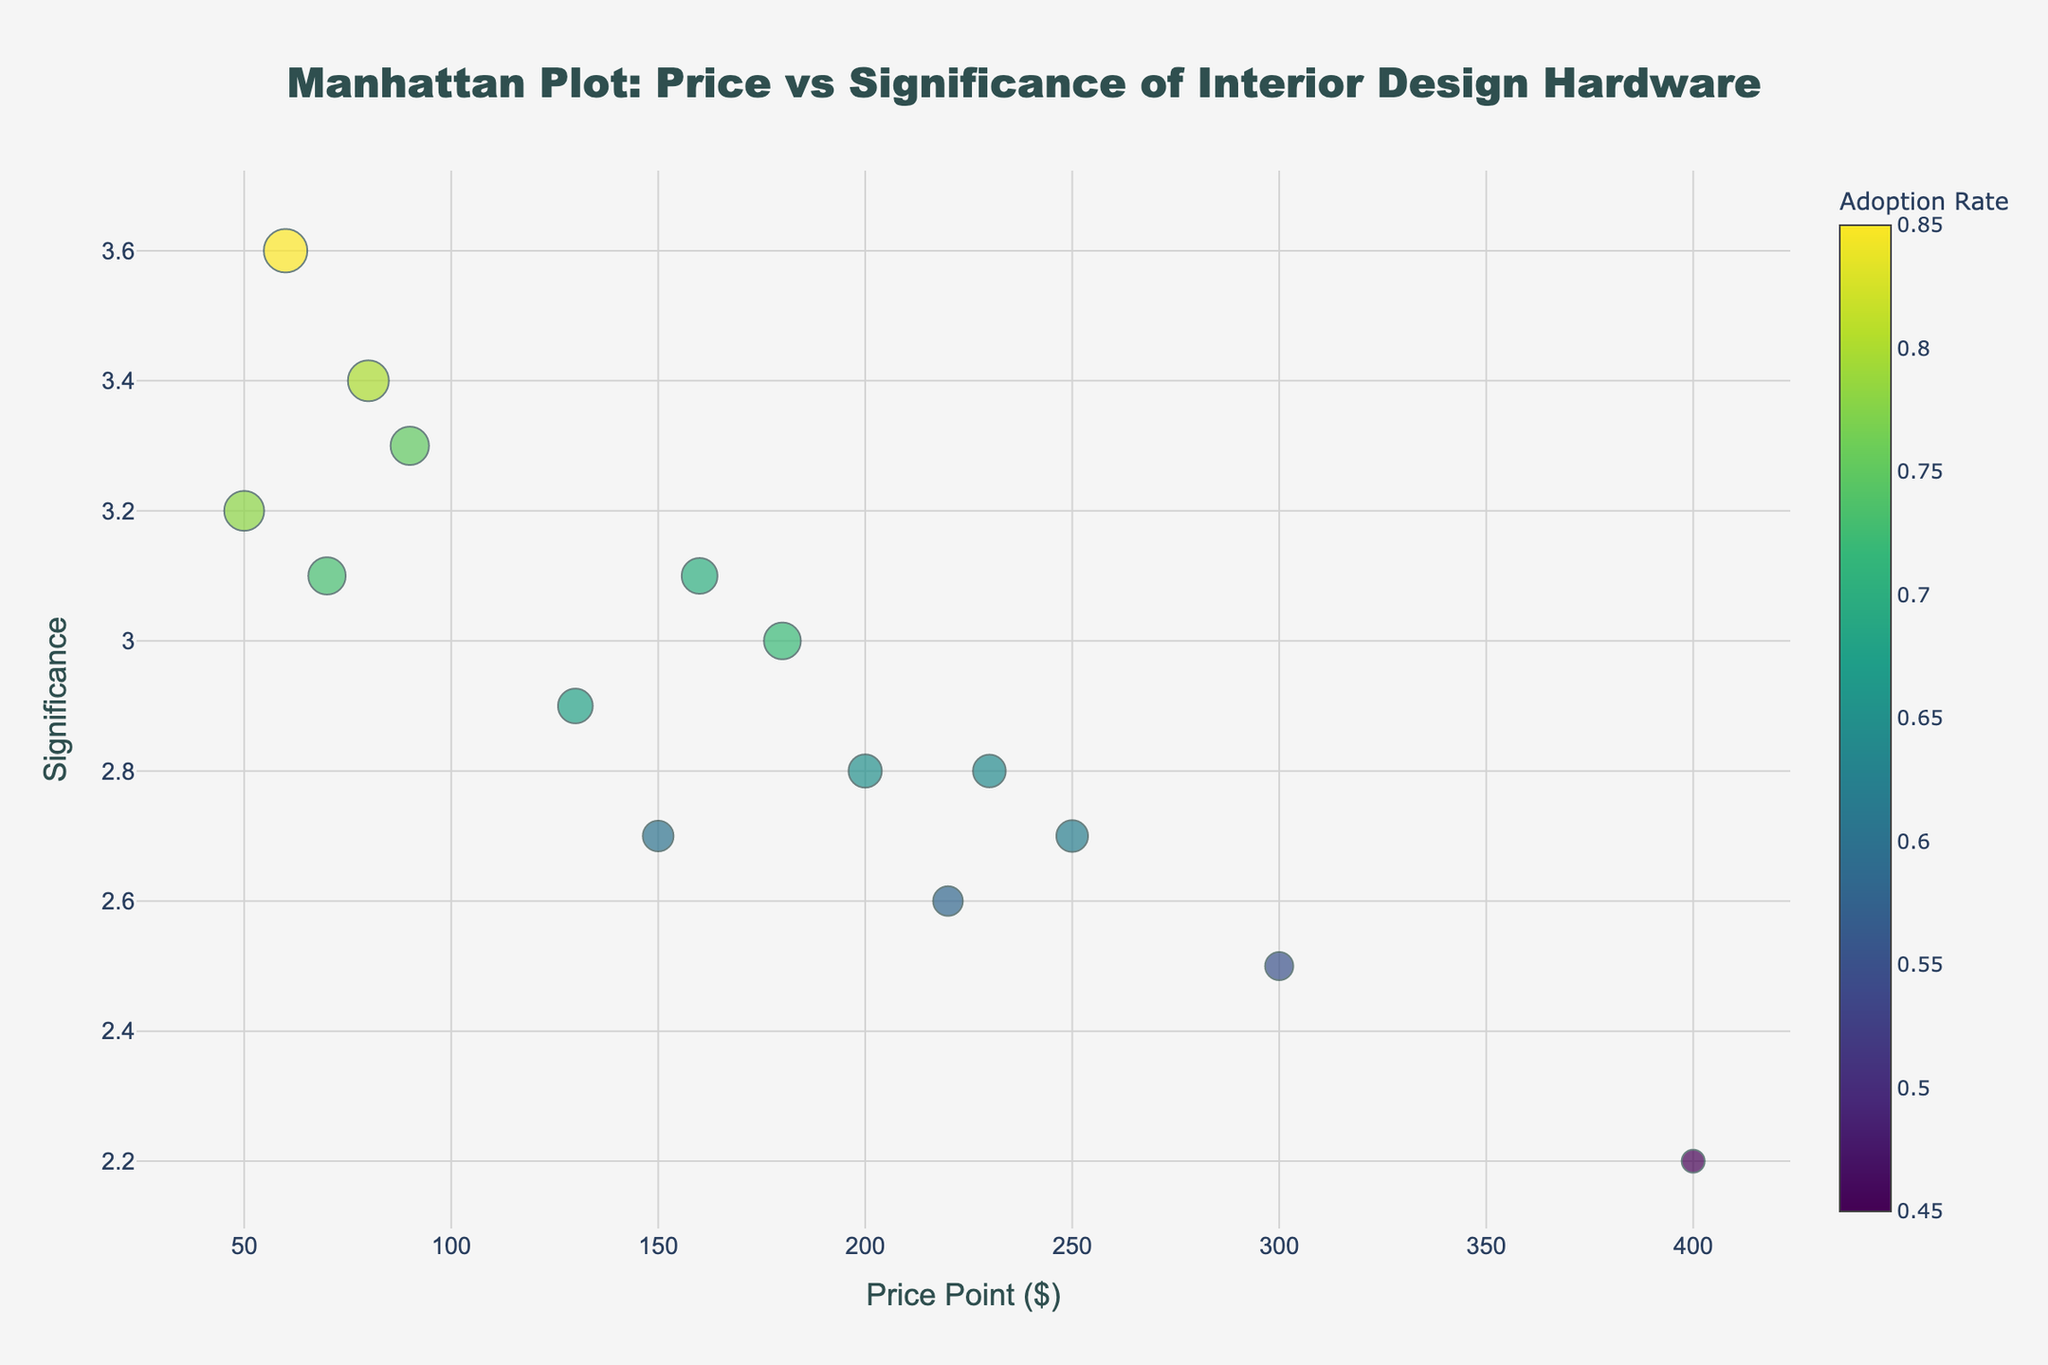How many products are represented in the plot? Count the number of distinct markers (points) on the plot, each representing a different product.
Answer: 15 What is the title of the plot? Read the text at the top of the plot.
Answer: Manhattan Plot: Price vs Significance of Interior Design Hardware Which product has the highest significance? Locate the point on the y-axis with the highest value, then refer to the hover text to find the corresponding product.
Answer: Smart Smoke Detector What is the price point of the Smart Mirror? Find and hover over the point labeled "Smart Mirror" to read its x-axis value.
Answer: $299.99 Which product has the lowest adoption rate? Identify the point with the smallest marker size and hover over it to find the product name.
Answer: Smart Glass Window How does the significance of the Gesture-Controlled Lighting compare to the Biometric Door Handle? Locate both products on the y-axis and compare their significance values. Gesture-Controlled Lighting is higher than Biometric Door Handle.
Answer: Gesture-Controlled Lighting has a higher significance Are there any products with the same significance value? Look for points that share the same value on the y-axis.
Answer: No Which product has the highest adoption rate for price points under $100? Locate all products on the x-axis with a price point below $100 and compare their adoption rates using the marker sizes.
Answer: Smart Smoke Detector What is the trend between price points and significance? Observe the spread and direction of the points on the plot generally from left to right. There is no clear trend between price points and significance.
Answer: No clear trend 